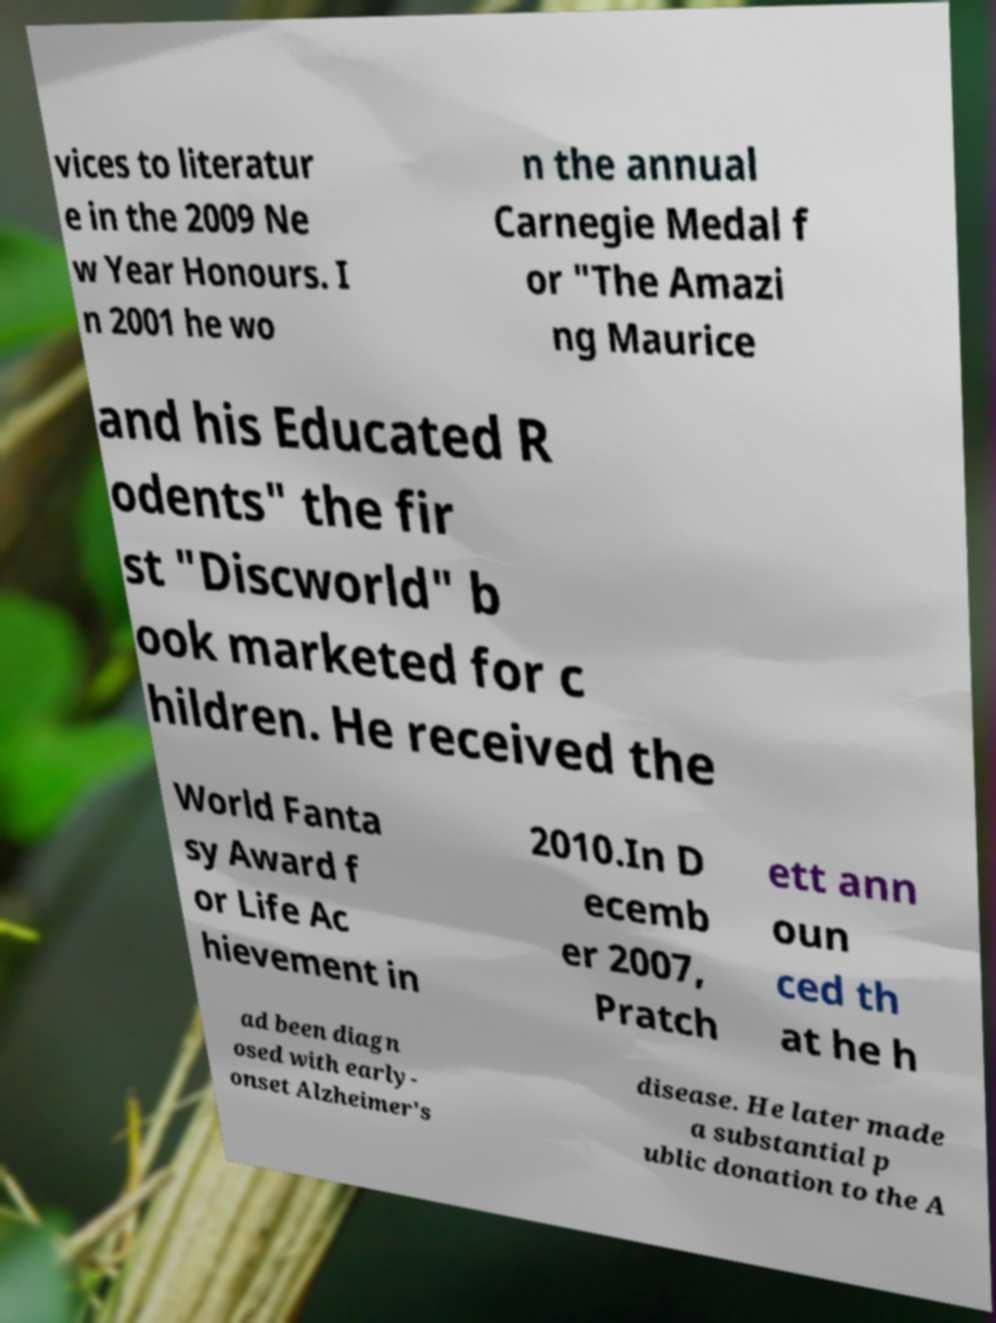Can you read and provide the text displayed in the image?This photo seems to have some interesting text. Can you extract and type it out for me? vices to literatur e in the 2009 Ne w Year Honours. I n 2001 he wo n the annual Carnegie Medal f or "The Amazi ng Maurice and his Educated R odents" the fir st "Discworld" b ook marketed for c hildren. He received the World Fanta sy Award f or Life Ac hievement in 2010.In D ecemb er 2007, Pratch ett ann oun ced th at he h ad been diagn osed with early- onset Alzheimer's disease. He later made a substantial p ublic donation to the A 